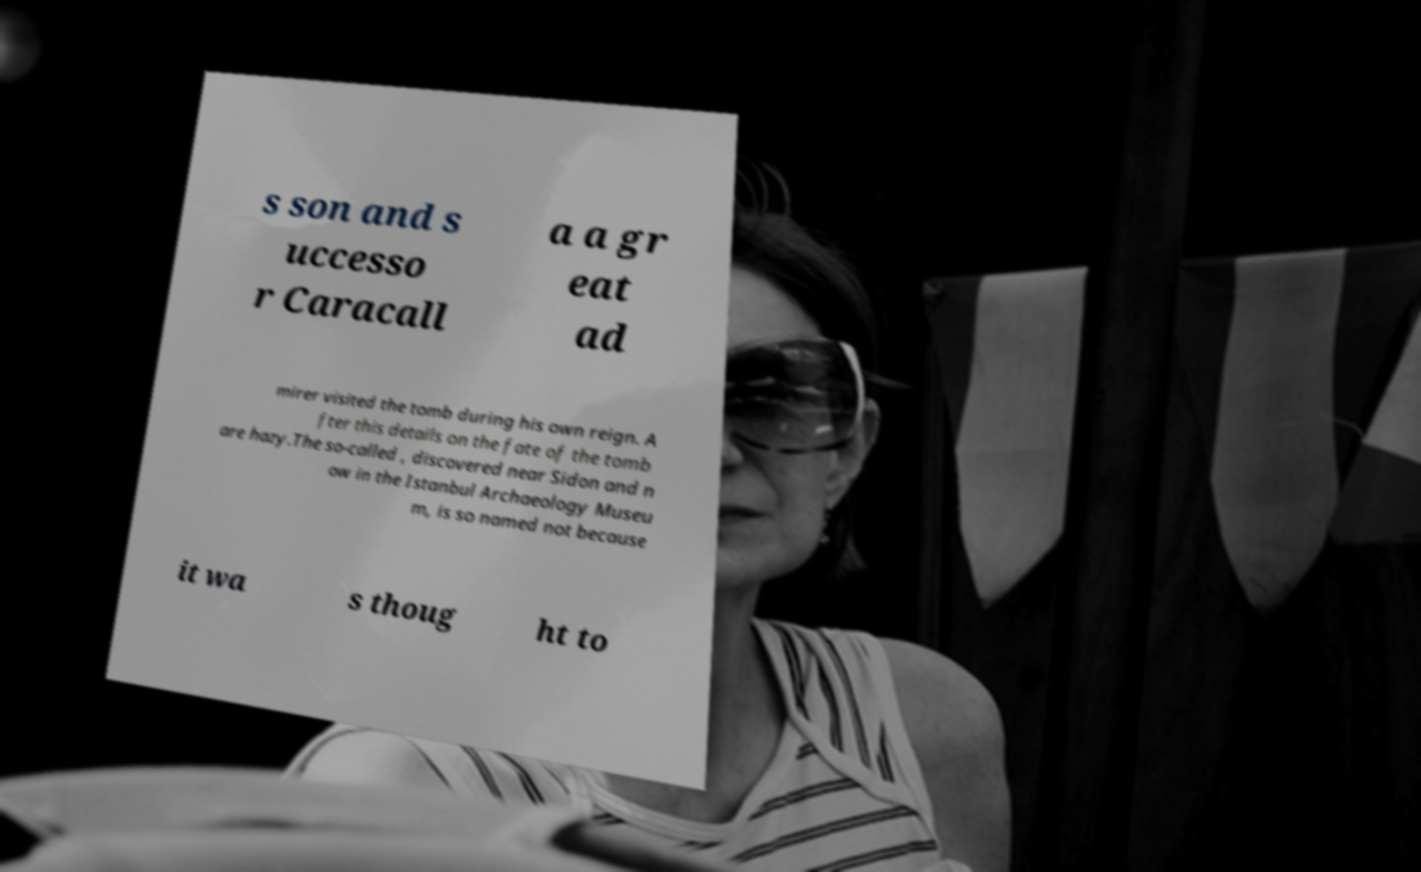Can you accurately transcribe the text from the provided image for me? s son and s uccesso r Caracall a a gr eat ad mirer visited the tomb during his own reign. A fter this details on the fate of the tomb are hazy.The so-called , discovered near Sidon and n ow in the Istanbul Archaeology Museu m, is so named not because it wa s thoug ht to 